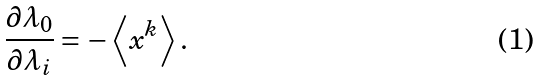Convert formula to latex. <formula><loc_0><loc_0><loc_500><loc_500>\frac { \partial \lambda _ { 0 } } { \partial \lambda _ { i } } = - \left \langle { x ^ { k } } \right \rangle .</formula> 